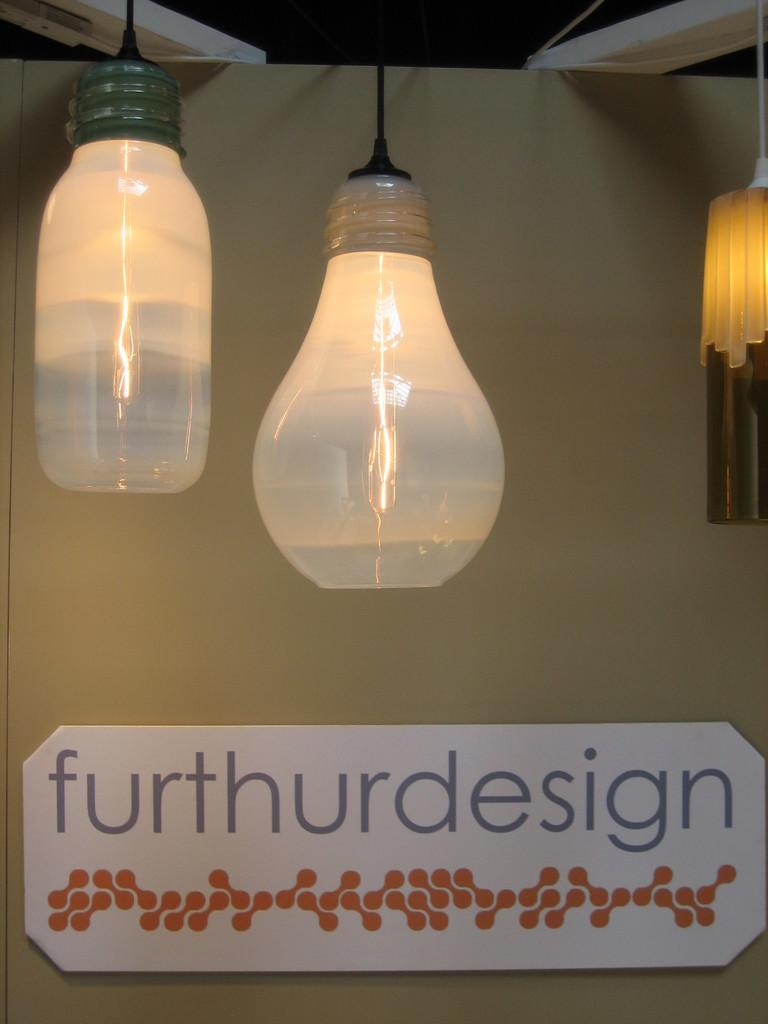<image>
Create a compact narrative representing the image presented. Light fixtures hang near a sign for furthurdesign. 